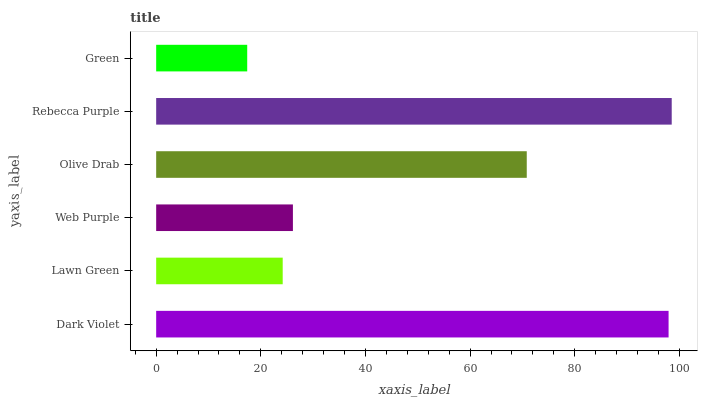Is Green the minimum?
Answer yes or no. Yes. Is Rebecca Purple the maximum?
Answer yes or no. Yes. Is Lawn Green the minimum?
Answer yes or no. No. Is Lawn Green the maximum?
Answer yes or no. No. Is Dark Violet greater than Lawn Green?
Answer yes or no. Yes. Is Lawn Green less than Dark Violet?
Answer yes or no. Yes. Is Lawn Green greater than Dark Violet?
Answer yes or no. No. Is Dark Violet less than Lawn Green?
Answer yes or no. No. Is Olive Drab the high median?
Answer yes or no. Yes. Is Web Purple the low median?
Answer yes or no. Yes. Is Green the high median?
Answer yes or no. No. Is Lawn Green the low median?
Answer yes or no. No. 